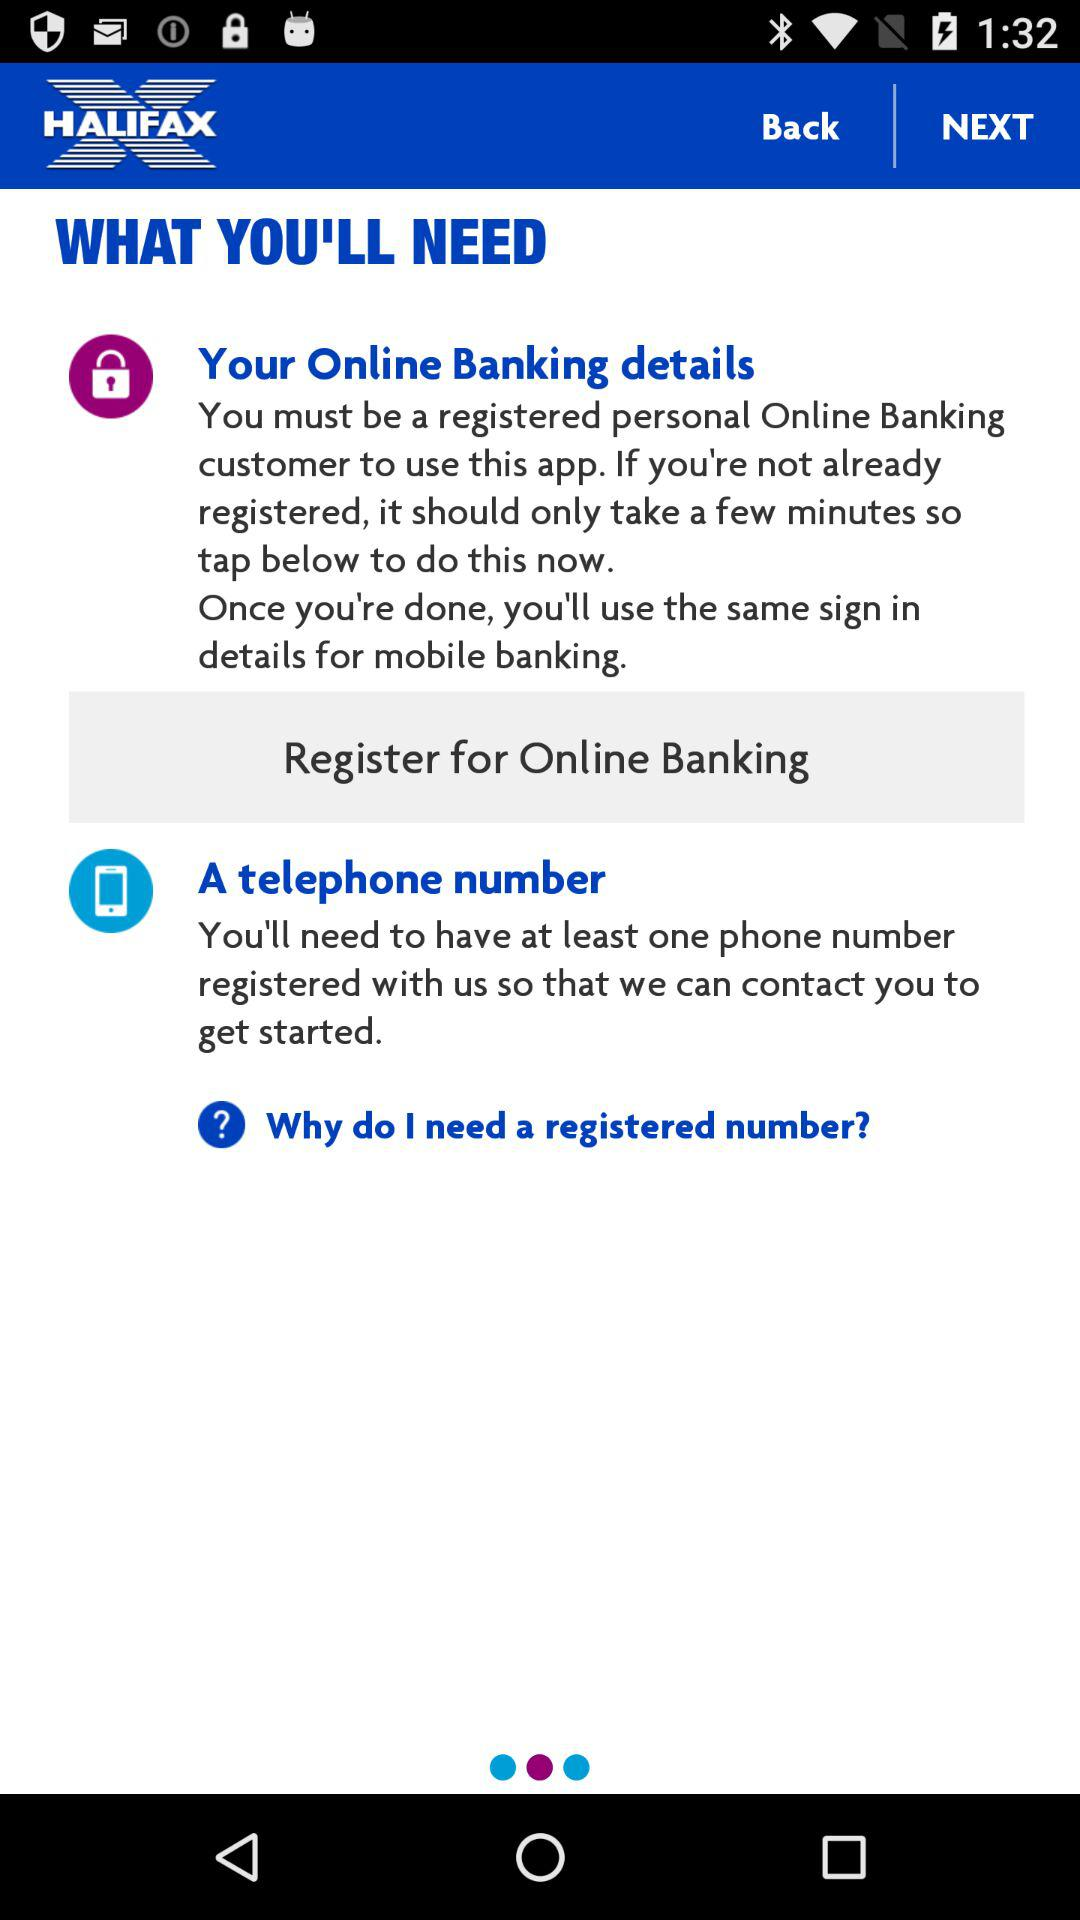What is the name of the application? The name of the application is "HALIFAX". 